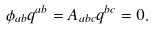<formula> <loc_0><loc_0><loc_500><loc_500>\phi _ { a b } q ^ { a b } = A _ { a b c } q ^ { b c } = 0 .</formula> 